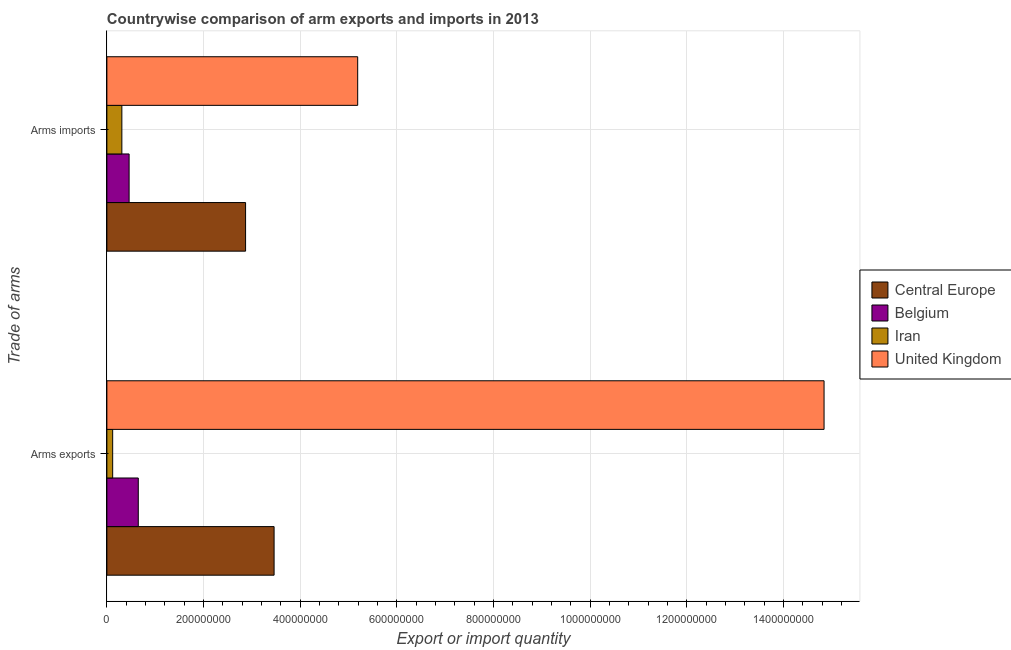How many groups of bars are there?
Ensure brevity in your answer.  2. Are the number of bars per tick equal to the number of legend labels?
Make the answer very short. Yes. How many bars are there on the 1st tick from the top?
Offer a terse response. 4. What is the label of the 1st group of bars from the top?
Provide a succinct answer. Arms imports. What is the arms imports in Iran?
Offer a very short reply. 3.10e+07. Across all countries, what is the maximum arms imports?
Give a very brief answer. 5.19e+08. Across all countries, what is the minimum arms imports?
Ensure brevity in your answer.  3.10e+07. In which country was the arms exports minimum?
Provide a short and direct response. Iran. What is the total arms imports in the graph?
Ensure brevity in your answer.  8.83e+08. What is the difference between the arms imports in Iran and that in Central Europe?
Offer a very short reply. -2.56e+08. What is the difference between the arms imports in Central Europe and the arms exports in Iran?
Ensure brevity in your answer.  2.75e+08. What is the average arms imports per country?
Your response must be concise. 2.21e+08. What is the difference between the arms exports and arms imports in Iran?
Provide a short and direct response. -1.90e+07. What is the ratio of the arms exports in Belgium to that in Central Europe?
Give a very brief answer. 0.19. In how many countries, is the arms imports greater than the average arms imports taken over all countries?
Offer a terse response. 2. What does the 1st bar from the top in Arms imports represents?
Provide a succinct answer. United Kingdom. What does the 2nd bar from the bottom in Arms exports represents?
Ensure brevity in your answer.  Belgium. Are the values on the major ticks of X-axis written in scientific E-notation?
Your response must be concise. No. How many legend labels are there?
Your response must be concise. 4. What is the title of the graph?
Provide a succinct answer. Countrywise comparison of arm exports and imports in 2013. Does "Trinidad and Tobago" appear as one of the legend labels in the graph?
Give a very brief answer. No. What is the label or title of the X-axis?
Your response must be concise. Export or import quantity. What is the label or title of the Y-axis?
Your response must be concise. Trade of arms. What is the Export or import quantity of Central Europe in Arms exports?
Provide a short and direct response. 3.46e+08. What is the Export or import quantity in Belgium in Arms exports?
Your answer should be compact. 6.50e+07. What is the Export or import quantity of United Kingdom in Arms exports?
Your answer should be compact. 1.48e+09. What is the Export or import quantity of Central Europe in Arms imports?
Ensure brevity in your answer.  2.87e+08. What is the Export or import quantity in Belgium in Arms imports?
Ensure brevity in your answer.  4.60e+07. What is the Export or import quantity in Iran in Arms imports?
Your answer should be compact. 3.10e+07. What is the Export or import quantity of United Kingdom in Arms imports?
Your answer should be very brief. 5.19e+08. Across all Trade of arms, what is the maximum Export or import quantity of Central Europe?
Make the answer very short. 3.46e+08. Across all Trade of arms, what is the maximum Export or import quantity of Belgium?
Give a very brief answer. 6.50e+07. Across all Trade of arms, what is the maximum Export or import quantity in Iran?
Provide a short and direct response. 3.10e+07. Across all Trade of arms, what is the maximum Export or import quantity of United Kingdom?
Provide a short and direct response. 1.48e+09. Across all Trade of arms, what is the minimum Export or import quantity of Central Europe?
Offer a very short reply. 2.87e+08. Across all Trade of arms, what is the minimum Export or import quantity in Belgium?
Provide a succinct answer. 4.60e+07. Across all Trade of arms, what is the minimum Export or import quantity of United Kingdom?
Ensure brevity in your answer.  5.19e+08. What is the total Export or import quantity of Central Europe in the graph?
Your answer should be very brief. 6.33e+08. What is the total Export or import quantity in Belgium in the graph?
Ensure brevity in your answer.  1.11e+08. What is the total Export or import quantity in Iran in the graph?
Offer a terse response. 4.30e+07. What is the total Export or import quantity of United Kingdom in the graph?
Ensure brevity in your answer.  2.00e+09. What is the difference between the Export or import quantity in Central Europe in Arms exports and that in Arms imports?
Provide a short and direct response. 5.90e+07. What is the difference between the Export or import quantity of Belgium in Arms exports and that in Arms imports?
Your answer should be very brief. 1.90e+07. What is the difference between the Export or import quantity of Iran in Arms exports and that in Arms imports?
Your answer should be compact. -1.90e+07. What is the difference between the Export or import quantity in United Kingdom in Arms exports and that in Arms imports?
Offer a terse response. 9.65e+08. What is the difference between the Export or import quantity of Central Europe in Arms exports and the Export or import quantity of Belgium in Arms imports?
Your answer should be very brief. 3.00e+08. What is the difference between the Export or import quantity of Central Europe in Arms exports and the Export or import quantity of Iran in Arms imports?
Ensure brevity in your answer.  3.15e+08. What is the difference between the Export or import quantity in Central Europe in Arms exports and the Export or import quantity in United Kingdom in Arms imports?
Keep it short and to the point. -1.73e+08. What is the difference between the Export or import quantity of Belgium in Arms exports and the Export or import quantity of Iran in Arms imports?
Keep it short and to the point. 3.40e+07. What is the difference between the Export or import quantity in Belgium in Arms exports and the Export or import quantity in United Kingdom in Arms imports?
Your answer should be very brief. -4.54e+08. What is the difference between the Export or import quantity in Iran in Arms exports and the Export or import quantity in United Kingdom in Arms imports?
Ensure brevity in your answer.  -5.07e+08. What is the average Export or import quantity in Central Europe per Trade of arms?
Your answer should be very brief. 3.16e+08. What is the average Export or import quantity in Belgium per Trade of arms?
Provide a succinct answer. 5.55e+07. What is the average Export or import quantity of Iran per Trade of arms?
Offer a very short reply. 2.15e+07. What is the average Export or import quantity of United Kingdom per Trade of arms?
Your answer should be compact. 1.00e+09. What is the difference between the Export or import quantity of Central Europe and Export or import quantity of Belgium in Arms exports?
Provide a succinct answer. 2.81e+08. What is the difference between the Export or import quantity of Central Europe and Export or import quantity of Iran in Arms exports?
Your answer should be very brief. 3.34e+08. What is the difference between the Export or import quantity in Central Europe and Export or import quantity in United Kingdom in Arms exports?
Make the answer very short. -1.14e+09. What is the difference between the Export or import quantity in Belgium and Export or import quantity in Iran in Arms exports?
Your response must be concise. 5.30e+07. What is the difference between the Export or import quantity in Belgium and Export or import quantity in United Kingdom in Arms exports?
Provide a succinct answer. -1.42e+09. What is the difference between the Export or import quantity in Iran and Export or import quantity in United Kingdom in Arms exports?
Provide a short and direct response. -1.47e+09. What is the difference between the Export or import quantity in Central Europe and Export or import quantity in Belgium in Arms imports?
Provide a succinct answer. 2.41e+08. What is the difference between the Export or import quantity of Central Europe and Export or import quantity of Iran in Arms imports?
Offer a terse response. 2.56e+08. What is the difference between the Export or import quantity in Central Europe and Export or import quantity in United Kingdom in Arms imports?
Ensure brevity in your answer.  -2.32e+08. What is the difference between the Export or import quantity of Belgium and Export or import quantity of Iran in Arms imports?
Provide a short and direct response. 1.50e+07. What is the difference between the Export or import quantity of Belgium and Export or import quantity of United Kingdom in Arms imports?
Your answer should be very brief. -4.73e+08. What is the difference between the Export or import quantity in Iran and Export or import quantity in United Kingdom in Arms imports?
Make the answer very short. -4.88e+08. What is the ratio of the Export or import quantity in Central Europe in Arms exports to that in Arms imports?
Make the answer very short. 1.21. What is the ratio of the Export or import quantity in Belgium in Arms exports to that in Arms imports?
Provide a succinct answer. 1.41. What is the ratio of the Export or import quantity in Iran in Arms exports to that in Arms imports?
Your answer should be compact. 0.39. What is the ratio of the Export or import quantity of United Kingdom in Arms exports to that in Arms imports?
Give a very brief answer. 2.86. What is the difference between the highest and the second highest Export or import quantity of Central Europe?
Give a very brief answer. 5.90e+07. What is the difference between the highest and the second highest Export or import quantity in Belgium?
Offer a very short reply. 1.90e+07. What is the difference between the highest and the second highest Export or import quantity in Iran?
Provide a succinct answer. 1.90e+07. What is the difference between the highest and the second highest Export or import quantity of United Kingdom?
Ensure brevity in your answer.  9.65e+08. What is the difference between the highest and the lowest Export or import quantity in Central Europe?
Offer a very short reply. 5.90e+07. What is the difference between the highest and the lowest Export or import quantity in Belgium?
Give a very brief answer. 1.90e+07. What is the difference between the highest and the lowest Export or import quantity of Iran?
Your response must be concise. 1.90e+07. What is the difference between the highest and the lowest Export or import quantity in United Kingdom?
Ensure brevity in your answer.  9.65e+08. 